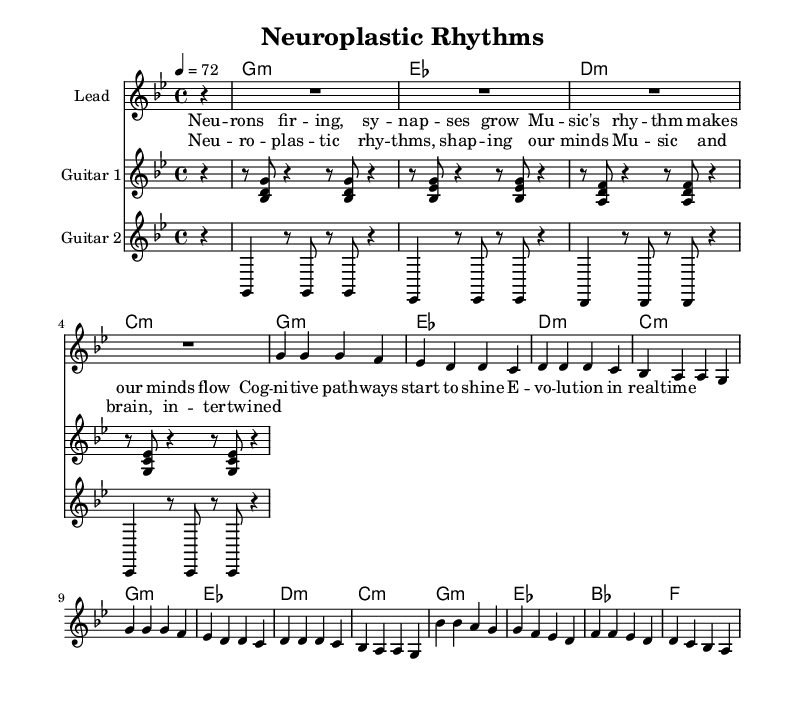What is the key signature of this music? The key signature shows two flats (B flat and E flat), indicating that the piece is in G minor, which is the relative minor of B flat major.
Answer: G minor What is the time signature of this music? The time signature is indicated at the beginning of the sheet music, showing a 4/4 signature, meaning there are four beats per measure, and the quarter note gets one beat.
Answer: 4/4 What is the tempo marking of the piece? The tempo marking located at the beginning states that the tempo is set to quarter note = 72 beats per minute, indicating a moderate pace for the song.
Answer: 72 How many measures are in the melody? Counting the measures represented in the melody section, there are a total of 12 measures present in the provided melody line.
Answer: 12 Which instruments are featured in this score? The score includes guitar parts and a lead section, specifically labeled as "Lead," "Guitar 1," and "Guitar 2," indicating the presence of these instruments.
Answer: Lead, Guitar 1, Guitar 2 What genre is this music classified under? The title as well as the rhythmic and melodic composition suggest that this piece is classified as Reggae, a genre known for its offbeat rhythms and laid-back style.
Answer: Reggae What is the thematic focus of the lyrics? The lyrics revolve around the themes of neuroplasticity, cognitive development, and how music influences the brain, suggesting an intricate relationship between music and human evolution.
Answer: Neuroplasticity, music, brain development 